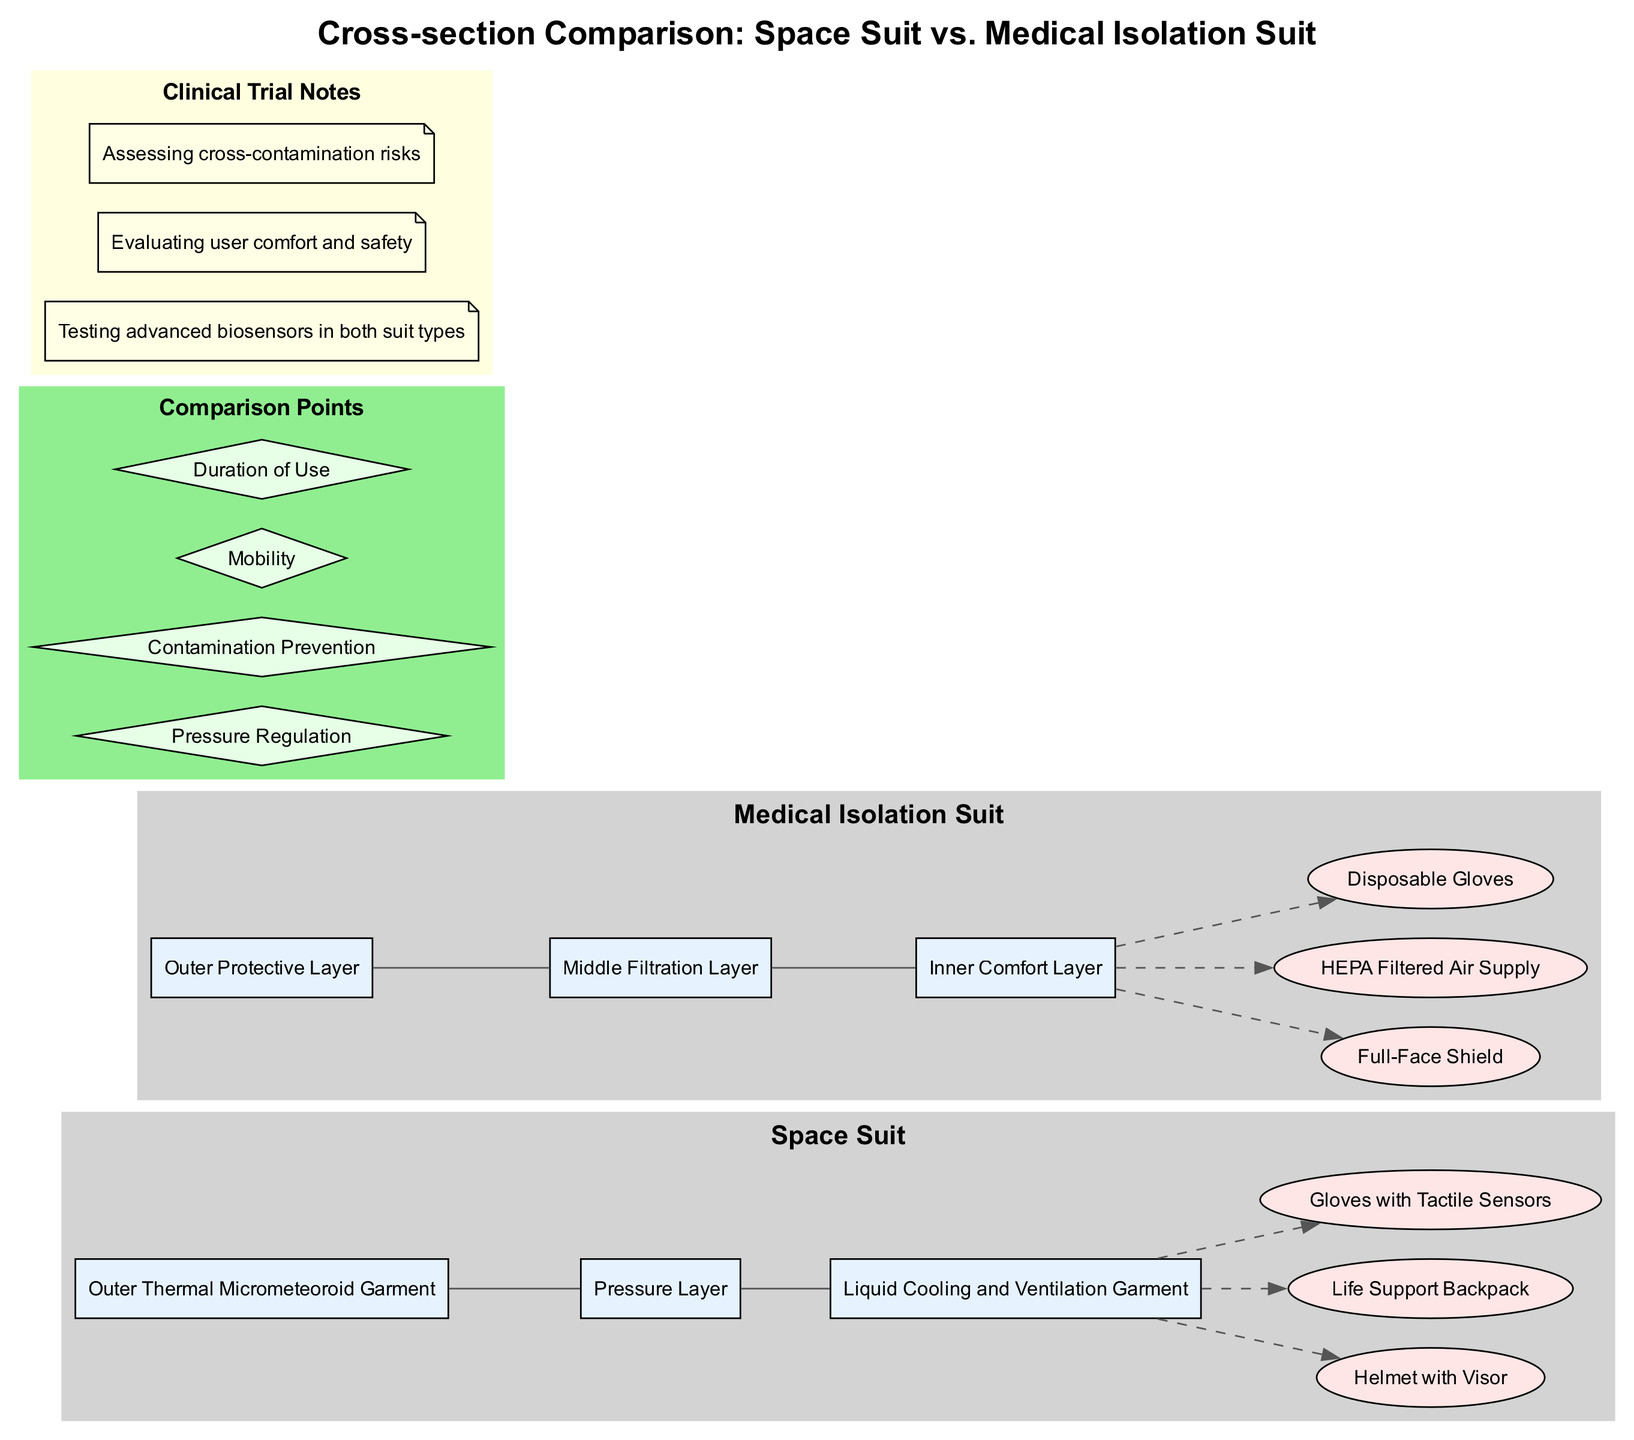What are the layers of the Space Suit? The layers of the Space Suit are listed as "Outer Thermal Micrometeoroid Garment", "Pressure Layer", and "Liquid Cooling and Ventilation Garment". These are directly shown in the diagram under the Space Suit component.
Answer: Outer Thermal Micrometeoroid Garment, Pressure Layer, Liquid Cooling and Ventilation Garment How many features does the Medical Isolation Suit have? The Medical Isolation Suit has three features, which are presented as elliptical nodes connected to the last layer of the suit. These features are listed specifically in the features section of the comparison.
Answer: Three What is the main purpose of the Pressure Regulation comparison point? The pressure regulation serves to maintain the necessary pressure environment for the user, which is crucial for the Space Suit as it operates in a vacuum, compared to the Medical Isolation Suit that does not require this. This can be inferred from the context and the specific design intentions of each suit type in the diagram.
Answer: Maintain necessary pressure environment Which suit has a full-face shield? The Medical Isolation Suit is the one that includes the full-face shield as one of its prominent features, which is distinctly categorized under the features section of that suit in the diagram.
Answer: Medical Isolation Suit List the comparison points shown in the diagram. The comparison points included in the diagram are "Pressure Regulation", "Contamination Prevention", "Mobility", and "Duration of Use". These points are indicated in the comparison section of the diagram, depicted as diamond-shaped nodes.
Answer: Pressure Regulation, Contamination Prevention, Mobility, Duration of Use What type of filter is used in the Medical Isolation Suit? The Medical Isolation Suit uses a HEPA filter, which is specified as one of its features. This information is provided in the features section of that suit in the diagram.
Answer: HEPA Filtered Air Supply How does the space suit ensure mobility compared to the medical isolation suit? The mobility of the Space Suit is designed to allow astronauts to move in a low-gravity environment, while the Medical Isolation Suit focuses on movement suited for medical protocols and contamination prevention. Comparison of specific design features and intended use leads to this understanding of their mobility differences.
Answer: Designed for low-gravity vs. medical protocols What clinical trial notes are associated with the diagram? The clinical trial notes listed are: "Testing advanced biosensors in both suit types", "Evaluating user comfort and safety", and "Assessing cross-contamination risks". These notes are found in the clinical trial notes section of the diagram.
Answer: Testing advanced biosensors, Evaluating user comfort and safety, Assessing cross-contamination risks 